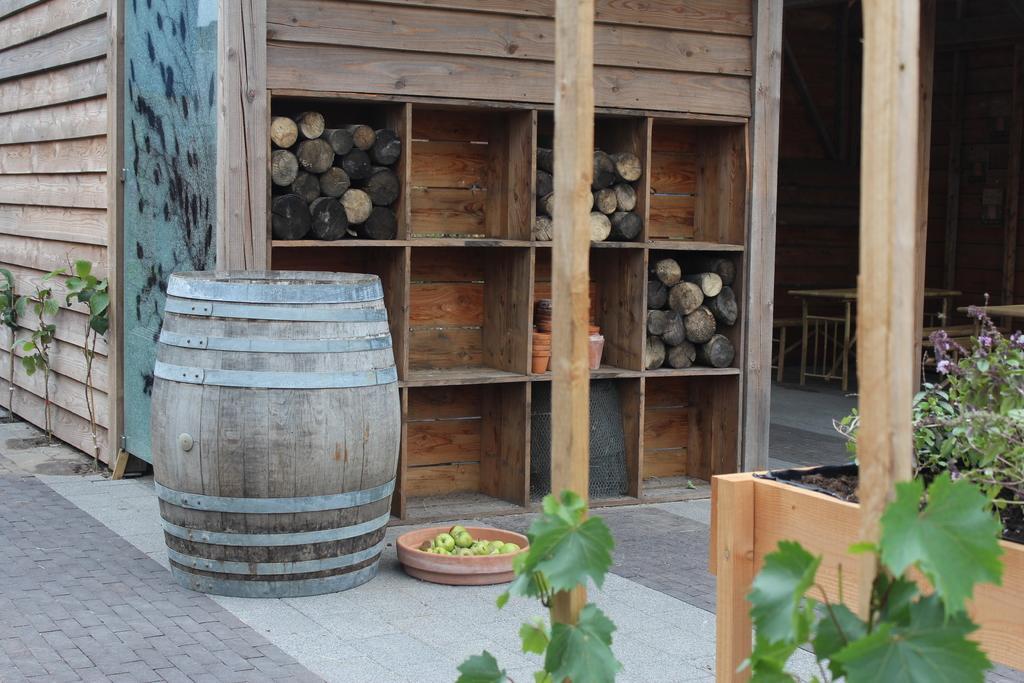Could you give a brief overview of what you see in this image? In this image There are some flowers on the bottom right corner of this image an is a wooden tub in middle of this image and there are some wooden things are on top of this image. There is a floor surface in the bottom of this image. 